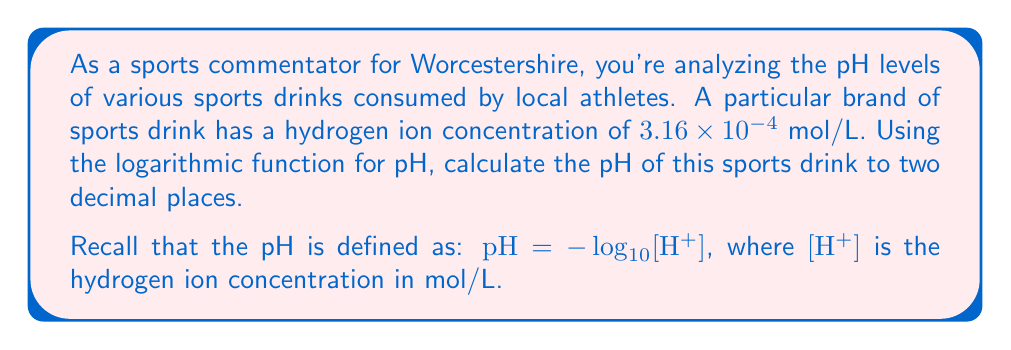Can you answer this question? Let's approach this step-by-step:

1) We're given that the hydrogen ion concentration $[H^+] = 3.16 \times 10^{-4}$ mol/L.

2) The formula for pH is:
   $pH = -\log_{10}[H^+]$

3) Let's substitute our value into the equation:
   $pH = -\log_{10}(3.16 \times 10^{-4})$

4) To solve this, we can use the properties of logarithms:
   $\log(a \times 10^n) = \log(a) + n$

5) Applying this:
   $pH = -(\log_{10}(3.16) + \log_{10}(10^{-4}))$
   $pH = -(0.4997 - 4)$

6) Simplifying:
   $pH = -0.4997 + 4 = 3.5003$

7) Rounding to two decimal places:
   $pH = 3.50$

This pH level indicates that the sports drink is acidic, which is typical for many sports drinks to enhance flavor and preservation.
Answer: $3.50$ 